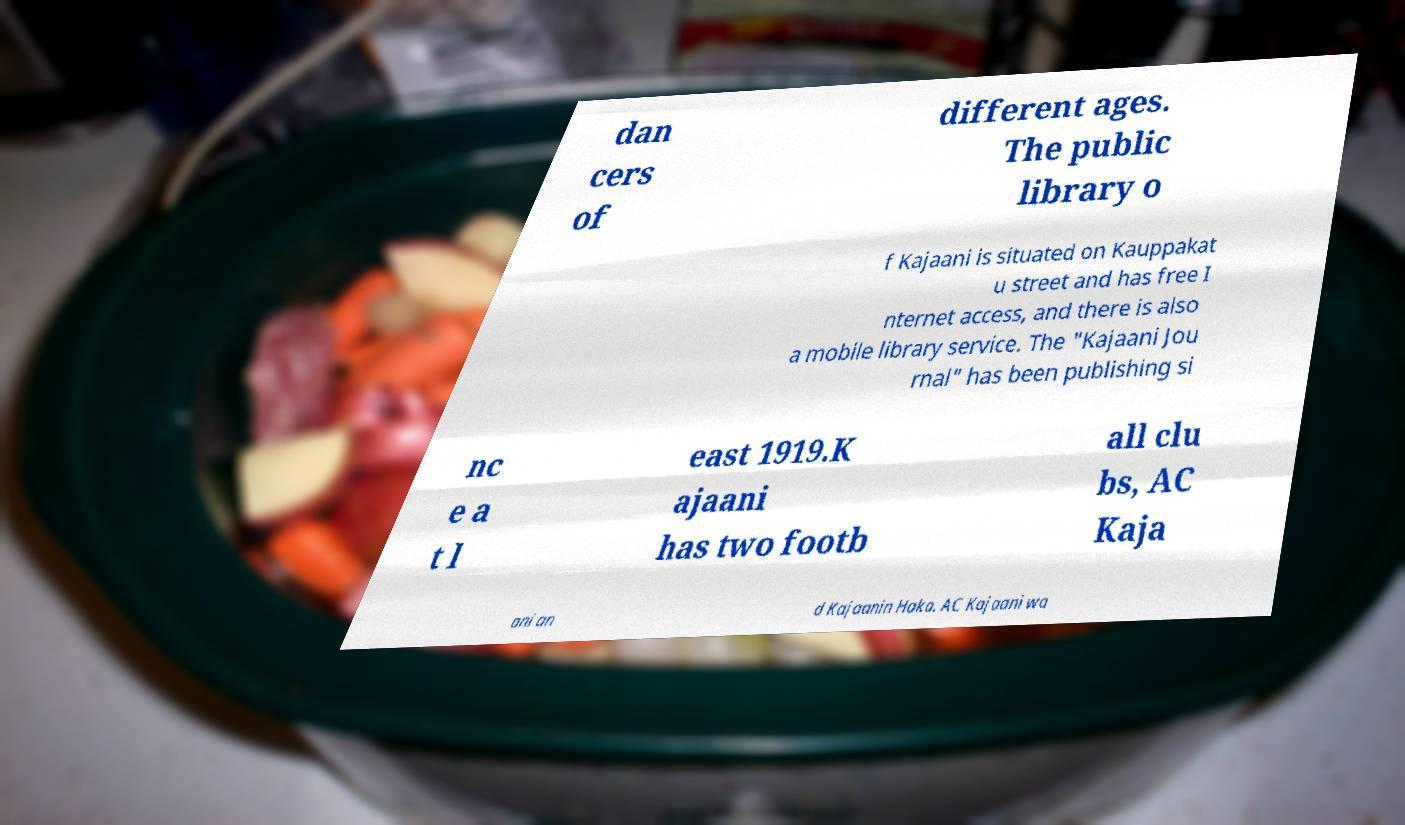I need the written content from this picture converted into text. Can you do that? dan cers of different ages. The public library o f Kajaani is situated on Kauppakat u street and has free I nternet access, and there is also a mobile library service. The "Kajaani Jou rnal" has been publishing si nc e a t l east 1919.K ajaani has two footb all clu bs, AC Kaja ani an d Kajaanin Haka. AC Kajaani wa 